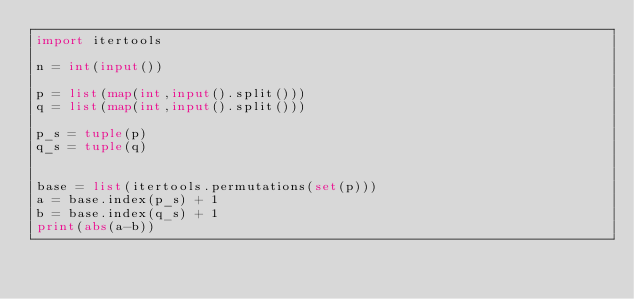<code> <loc_0><loc_0><loc_500><loc_500><_Python_>import itertools

n = int(input())

p = list(map(int,input().split()))
q = list(map(int,input().split()))

p_s = tuple(p)
q_s = tuple(q)


base = list(itertools.permutations(set(p)))
a = base.index(p_s) + 1
b = base.index(q_s) + 1
print(abs(a-b))</code> 